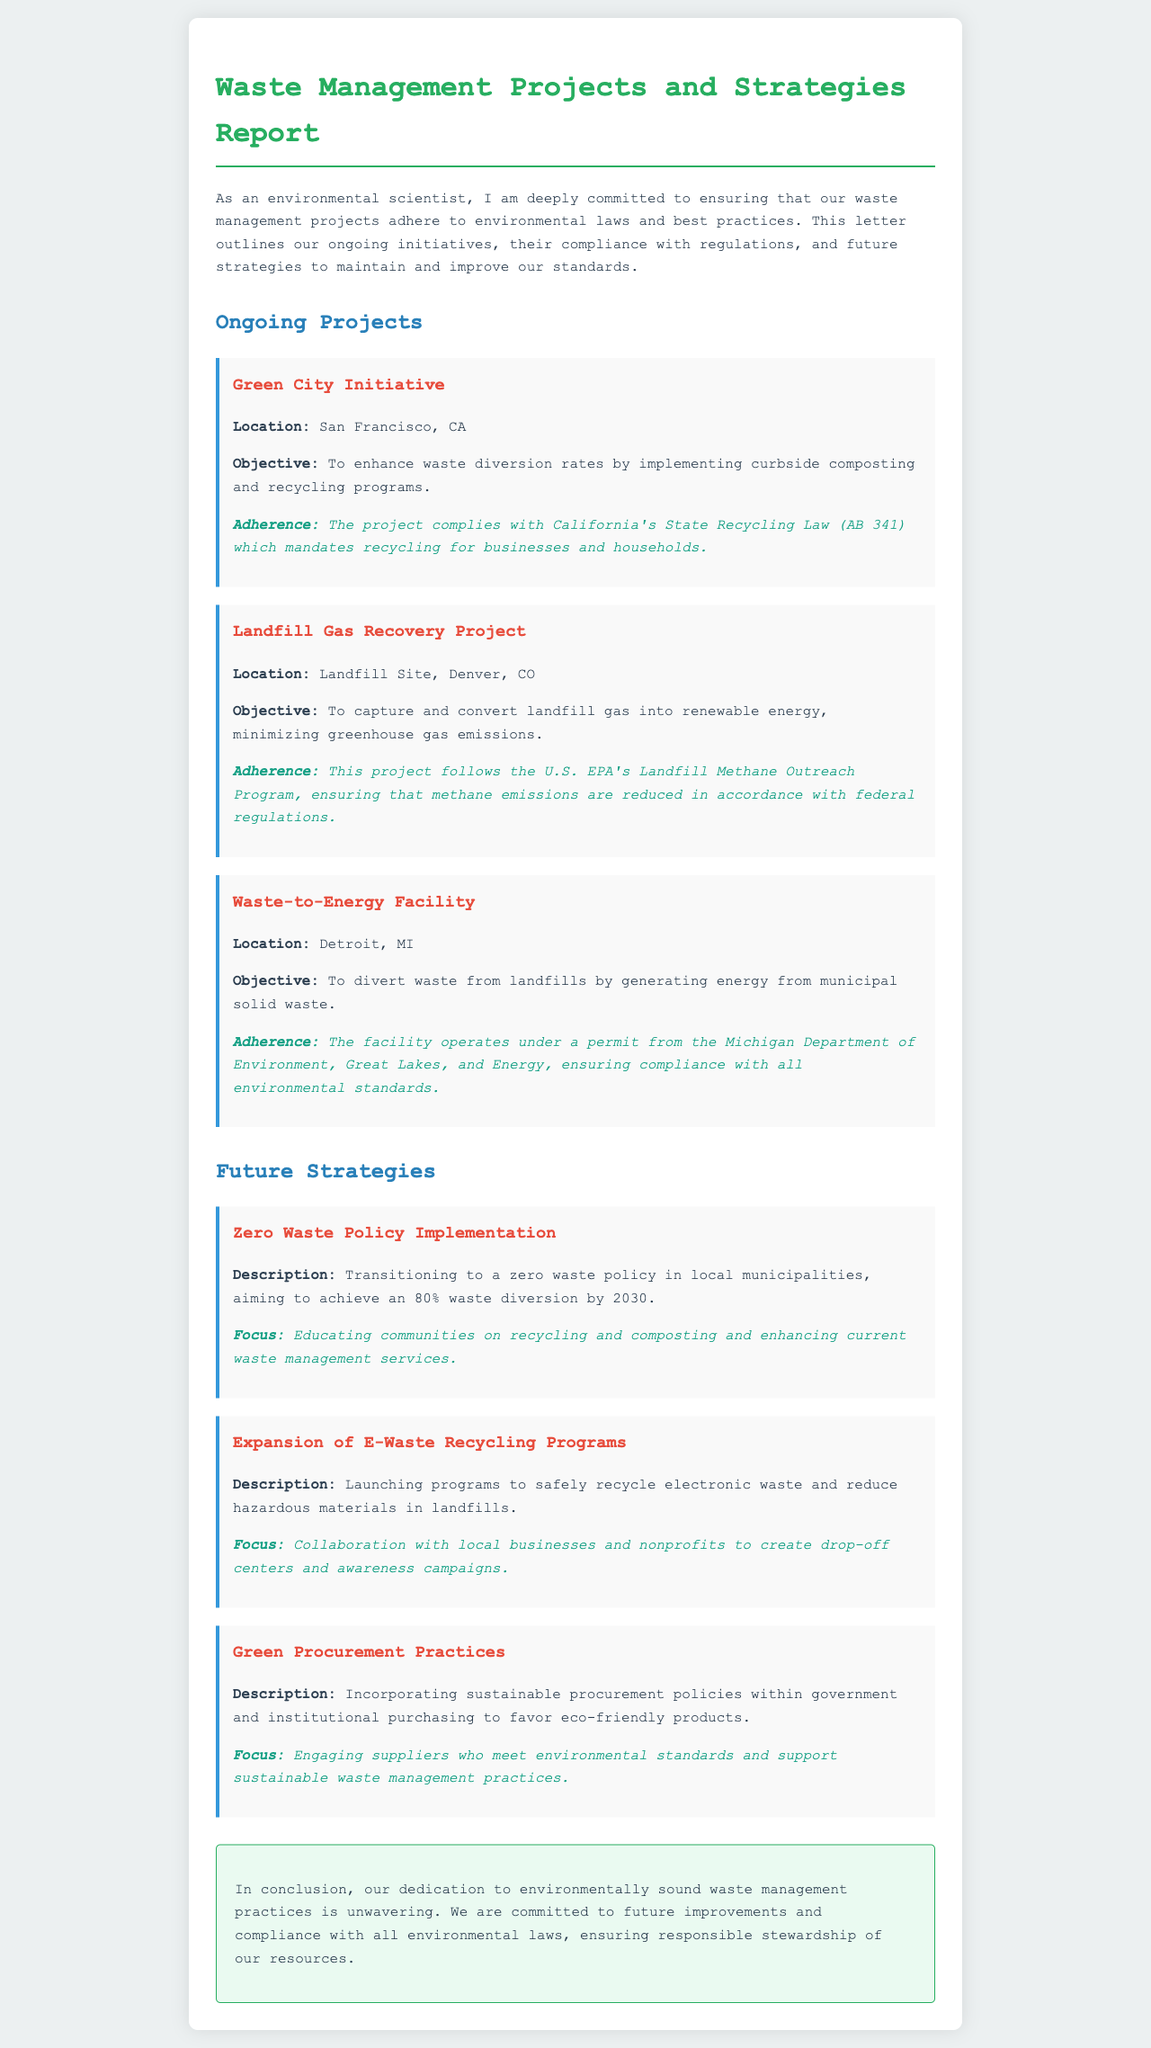what is the location of the Green City Initiative? The document mentions that the Green City Initiative is located in San Francisco, CA.
Answer: San Francisco, CA what objective does the Landfill Gas Recovery Project aim to achieve? The objective of the Landfill Gas Recovery Project is to capture and convert landfill gas into renewable energy.
Answer: Capture and convert landfill gas into renewable energy which environmental law does the Green City Initiative comply with? The project complies with California's State Recycling Law (AB 341).
Answer: California's State Recycling Law (AB 341) what is the focus of the Zero Waste Policy Implementation strategy? The focus of the Zero Waste Policy Implementation strategy is educating communities on recycling and composting.
Answer: Educating communities on recycling and composting how many waste diversion does the Zero Waste Policy aim to achieve by 2030? The document specifies that the goal is to achieve an 80% waste diversion by 2030.
Answer: 80% what project operates under a permit from the Michigan Department of Environment? The Waste-to-Energy Facility operates under a permit from the Michigan Department of Environment.
Answer: Waste-to-Energy Facility what is the purpose of the E-Waste Recycling Programs? The purpose of the E-Waste Recycling Programs is to safely recycle electronic waste.
Answer: Safely recycle electronic waste what is one future strategy mentioned in the document? The document mentions several strategies, one of which is the expansion of E-Waste Recycling Programs.
Answer: Expansion of E-Waste Recycling Programs what color is used for the title of the report? The title of the report is styled in a green color.
Answer: Green 